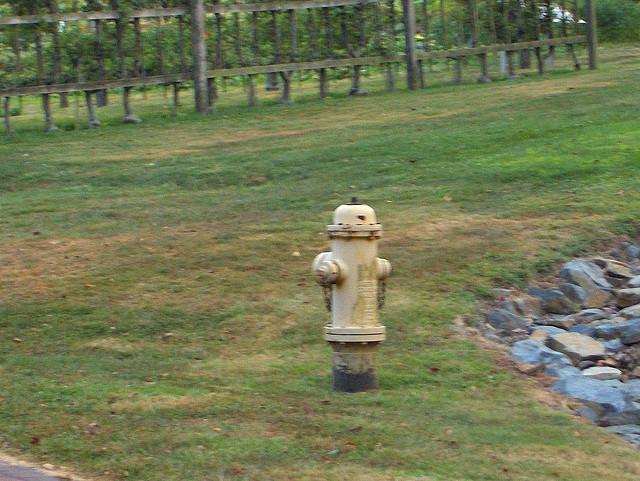How tall is the hydrant?
Keep it brief. 2 feet. What kind of fencing is at the far edge of the lawn?
Answer briefly. Wooden. What color is the fire hydrant?
Short answer required. Yellow. Is the fire hydrant spraying water?
Write a very short answer. No. What is the yellow object?
Give a very brief answer. Fire hydrant. Does the hydrant have eyes?
Short answer required. No. Is the fire hydrant painted blue?
Write a very short answer. No. Are there cars in the picture?
Quick response, please. No. 